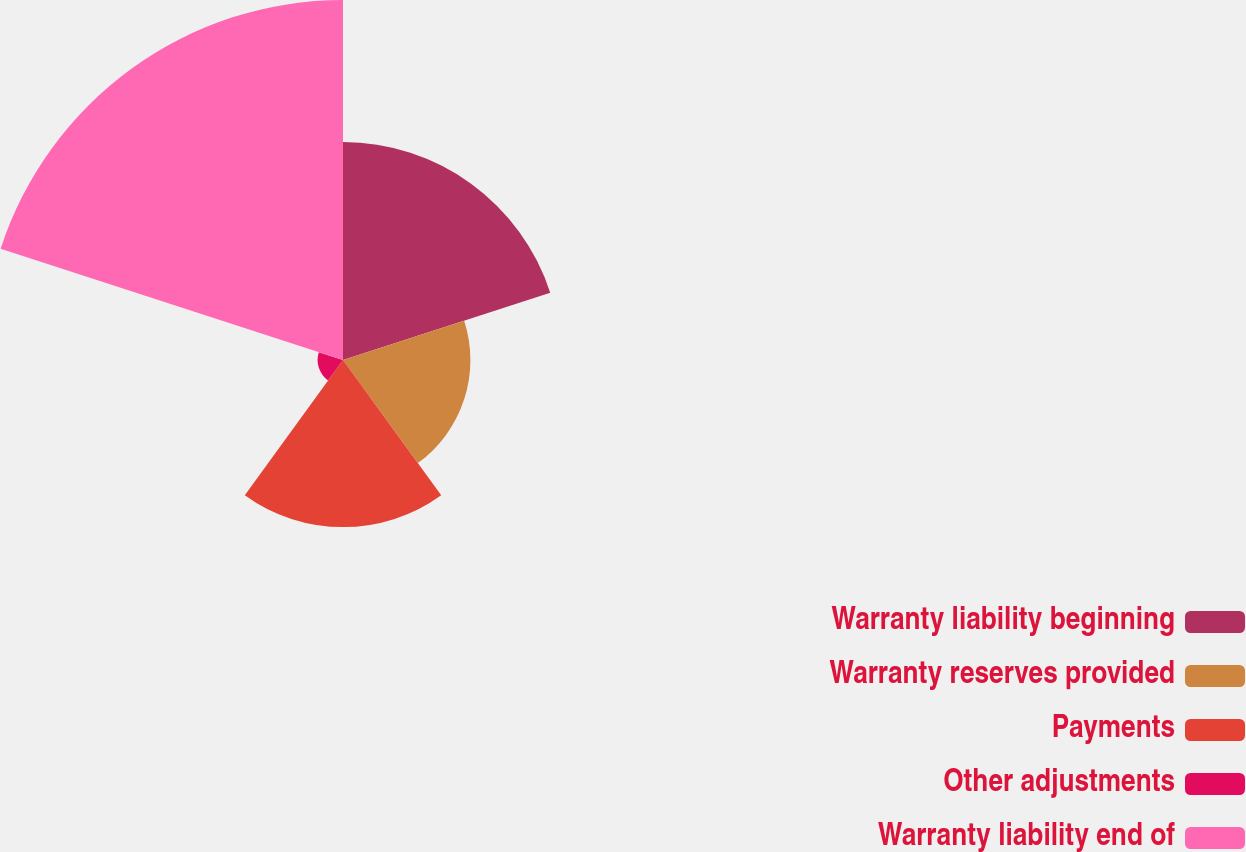Convert chart. <chart><loc_0><loc_0><loc_500><loc_500><pie_chart><fcel>Warranty liability beginning<fcel>Warranty reserves provided<fcel>Payments<fcel>Other adjustments<fcel>Warranty liability end of<nl><fcel>24.27%<fcel>14.19%<fcel>18.61%<fcel>2.83%<fcel>40.1%<nl></chart> 